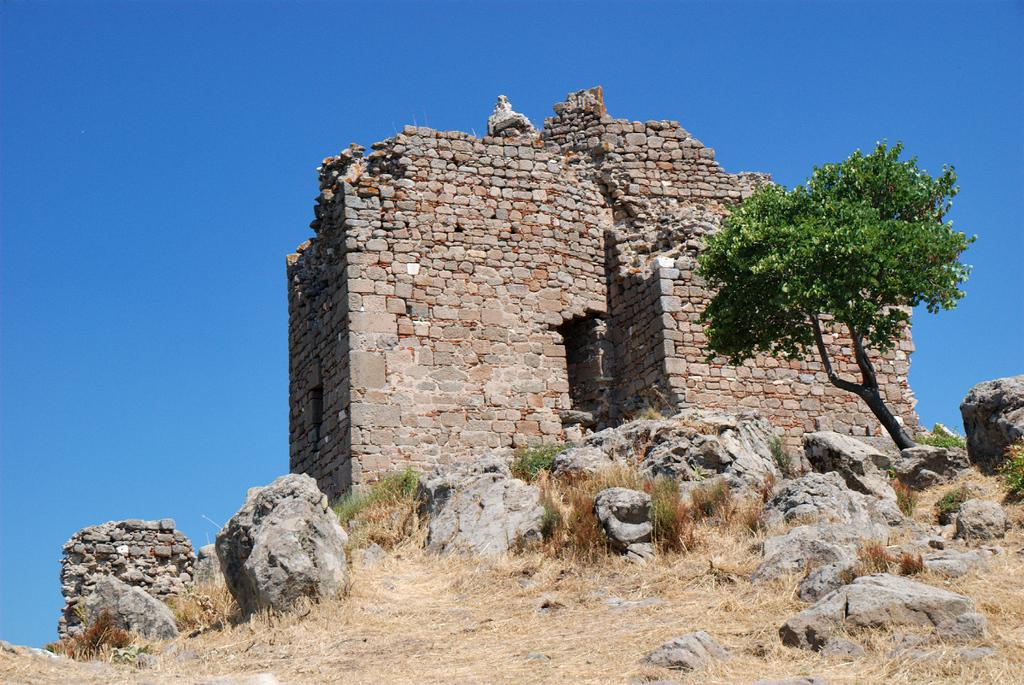What type of terrain is visible in the image? There is a grassy land in the image. What other elements can be seen at the bottom of the image? Rocks are present at the bottom of the image. What is the main feature in the middle of the image? There is a monument in the middle of the image. Are there any trees visible in the image? Yes, there is a tree in the middle of the image. What color is the sky in the background of the image? The sky is blue in the background of the image. How many clams are sitting on the monument in the image? There are no clams present in the image; the monument is not associated with clams. What type of pizzas can be seen being pulled out of the tree in the image? There are no pizzas present in the image, and pizzas cannot be pulled out of trees. 